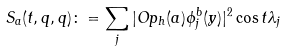<formula> <loc_0><loc_0><loc_500><loc_500>S _ { a } ( t , q , q ) \colon = \sum _ { j } | O p _ { h } ( a ) \phi ^ { b } _ { j } ( y ) | ^ { 2 } \cos t \lambda _ { j }</formula> 